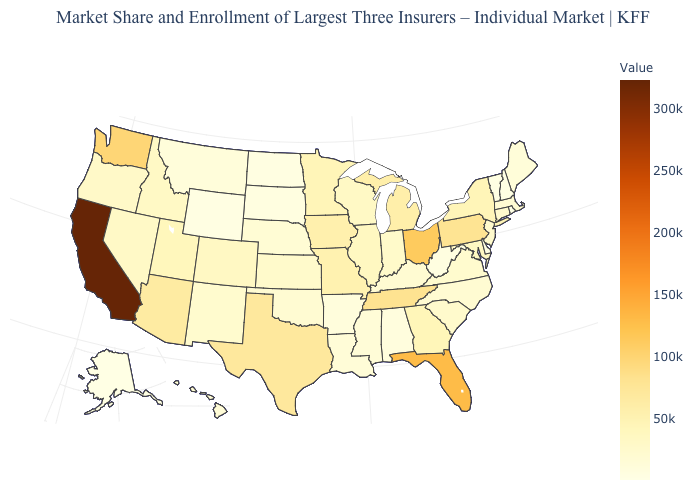Which states hav the highest value in the South?
Answer briefly. Florida. Which states have the lowest value in the USA?
Be succinct. Rhode Island. Does Washington have a higher value than Alaska?
Quick response, please. Yes. Among the states that border Arizona , does California have the lowest value?
Keep it brief. No. Does Georgia have a higher value than Rhode Island?
Give a very brief answer. Yes. Does Ohio have the highest value in the MidWest?
Quick response, please. Yes. Among the states that border Wyoming , which have the lowest value?
Concise answer only. South Dakota. Which states hav the highest value in the South?
Give a very brief answer. Florida. 